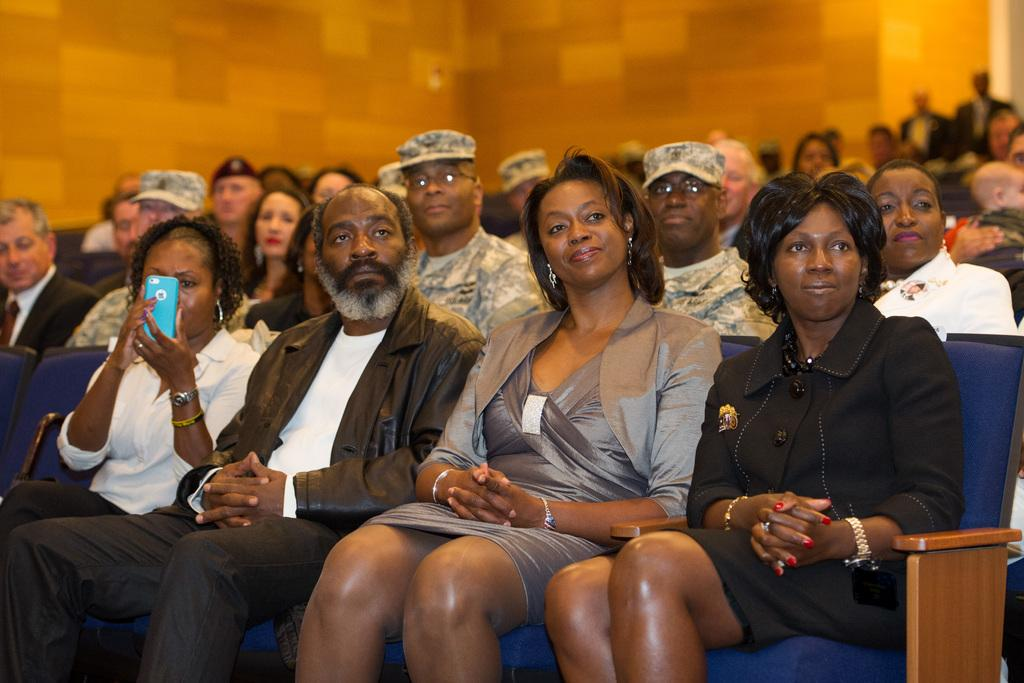How many people are in the image? There are persons in the image, but the exact number is not specified. What are the persons wearing? The persons are wearing clothes. What are the persons doing in the image? The persons are sitting on chairs. What can be seen at the top of the image? There is a wall visible at the top of the image. What decision did the person make about their wrist in the image? There is no mention of a decision or a wrist in the image, so it is not possible to answer this question. 